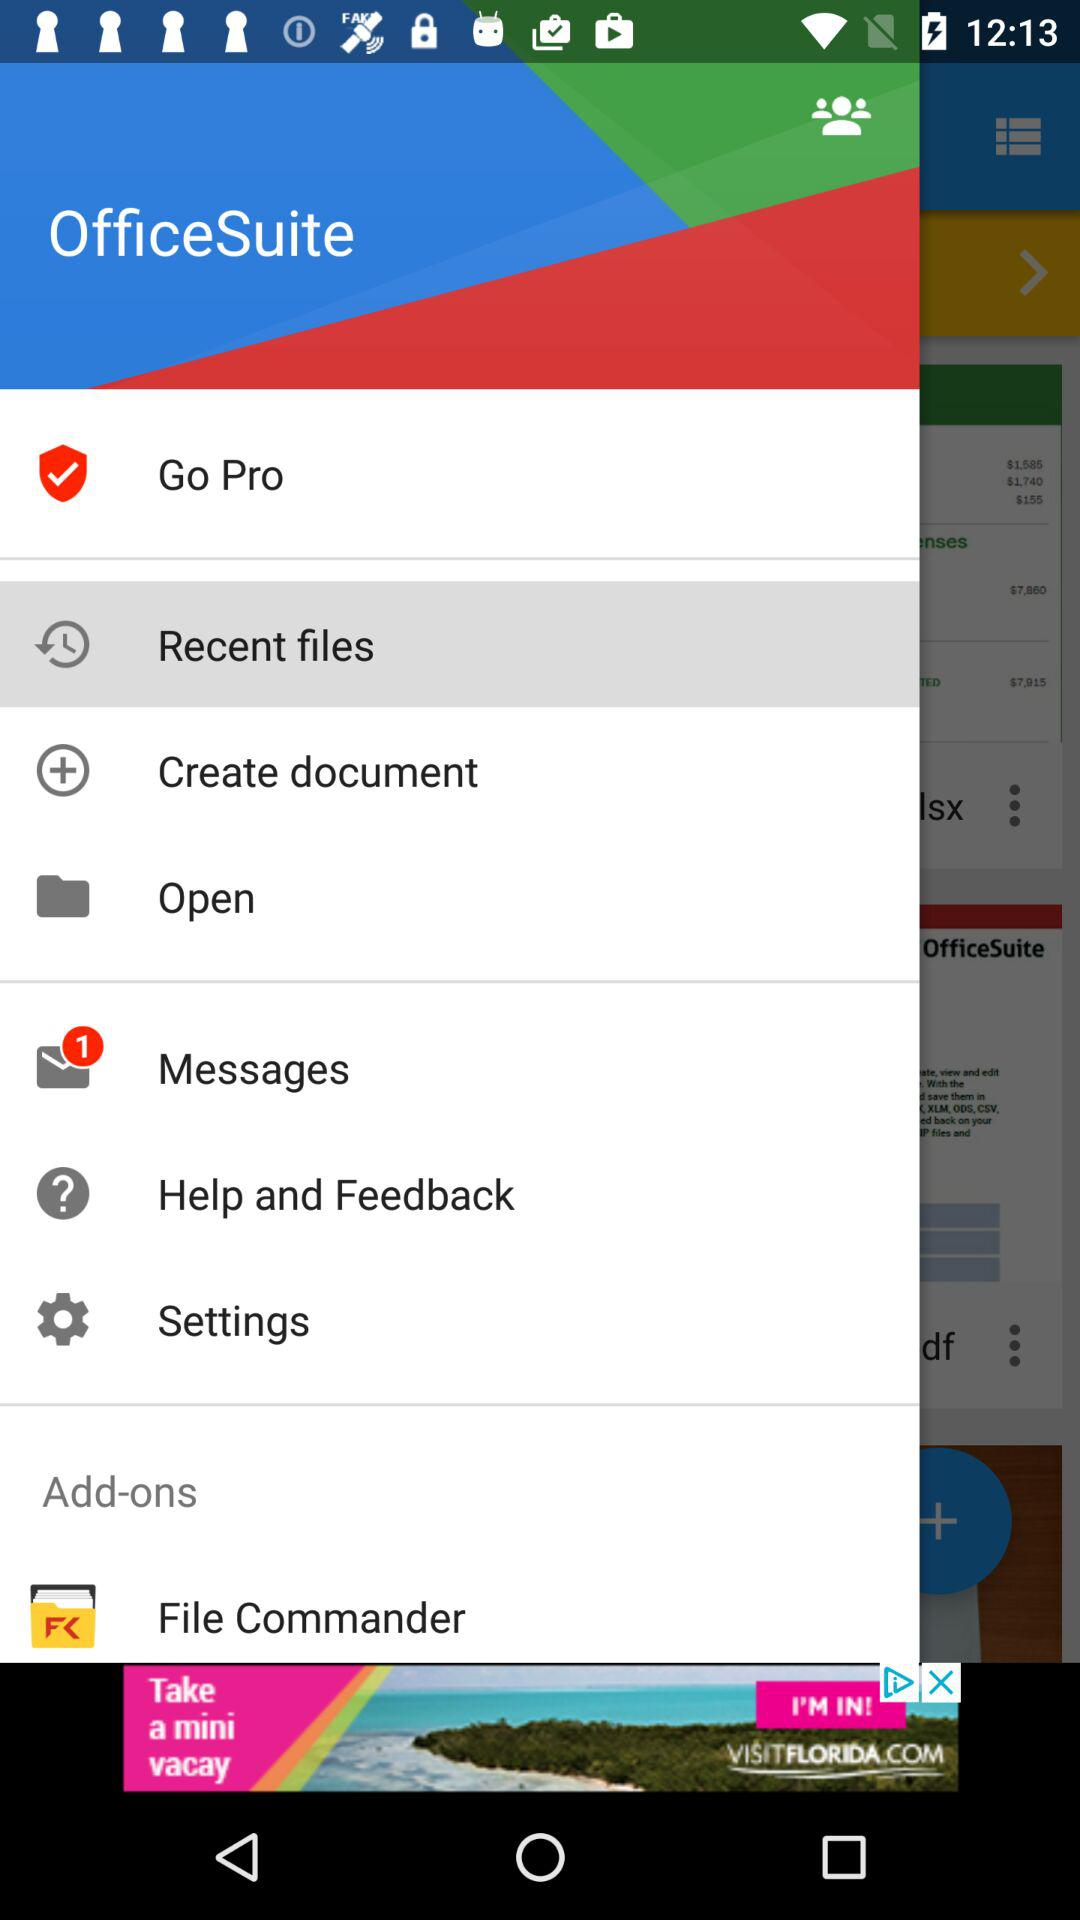Which is the selected item in the menu? The selected item in the menu is "Recent files". 